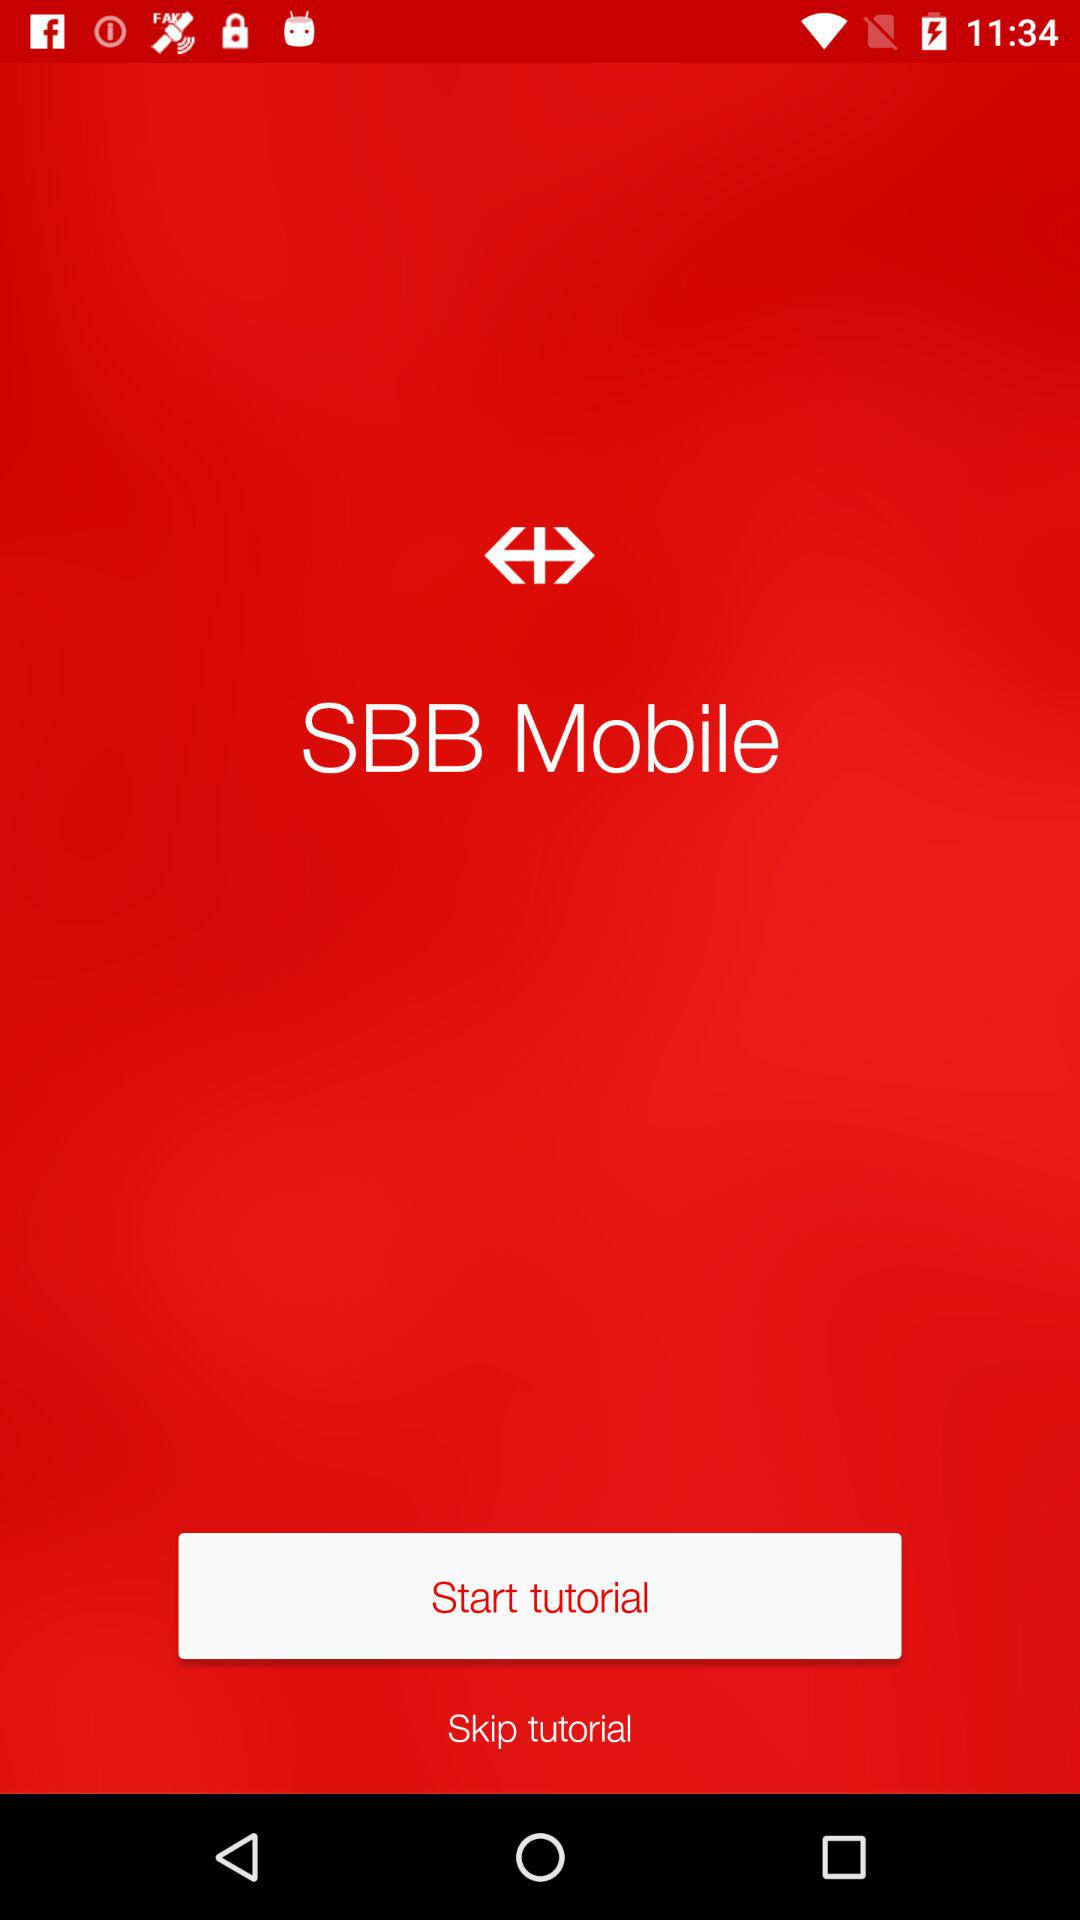What is the application name? The application name is "SBB Mobile". 